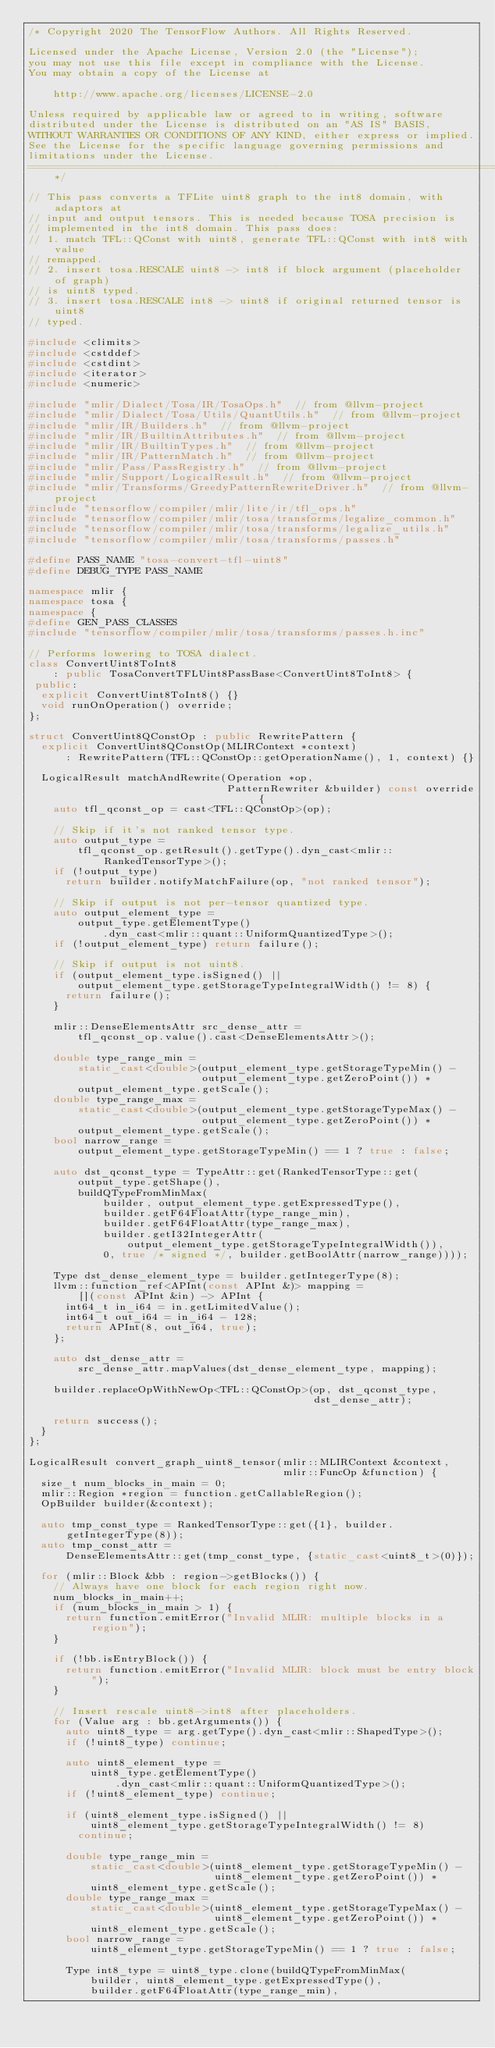Convert code to text. <code><loc_0><loc_0><loc_500><loc_500><_C++_>/* Copyright 2020 The TensorFlow Authors. All Rights Reserved.

Licensed under the Apache License, Version 2.0 (the "License");
you may not use this file except in compliance with the License.
You may obtain a copy of the License at

    http://www.apache.org/licenses/LICENSE-2.0

Unless required by applicable law or agreed to in writing, software
distributed under the License is distributed on an "AS IS" BASIS,
WITHOUT WARRANTIES OR CONDITIONS OF ANY KIND, either express or implied.
See the License for the specific language governing permissions and
limitations under the License.
==============================================================================*/

// This pass converts a TFLite uint8 graph to the int8 domain, with adaptors at
// input and output tensors. This is needed because TOSA precision is
// implemented in the int8 domain. This pass does:
// 1. match TFL::QConst with uint8, generate TFL::QConst with int8 with value
// remapped.
// 2. insert tosa.RESCALE uint8 -> int8 if block argument (placeholder of graph)
// is uint8 typed.
// 3. insert tosa.RESCALE int8 -> uint8 if original returned tensor is uint8
// typed.

#include <climits>
#include <cstddef>
#include <cstdint>
#include <iterator>
#include <numeric>

#include "mlir/Dialect/Tosa/IR/TosaOps.h"  // from @llvm-project
#include "mlir/Dialect/Tosa/Utils/QuantUtils.h"  // from @llvm-project
#include "mlir/IR/Builders.h"  // from @llvm-project
#include "mlir/IR/BuiltinAttributes.h"  // from @llvm-project
#include "mlir/IR/BuiltinTypes.h"  // from @llvm-project
#include "mlir/IR/PatternMatch.h"  // from @llvm-project
#include "mlir/Pass/PassRegistry.h"  // from @llvm-project
#include "mlir/Support/LogicalResult.h"  // from @llvm-project
#include "mlir/Transforms/GreedyPatternRewriteDriver.h"  // from @llvm-project
#include "tensorflow/compiler/mlir/lite/ir/tfl_ops.h"
#include "tensorflow/compiler/mlir/tosa/transforms/legalize_common.h"
#include "tensorflow/compiler/mlir/tosa/transforms/legalize_utils.h"
#include "tensorflow/compiler/mlir/tosa/transforms/passes.h"

#define PASS_NAME "tosa-convert-tfl-uint8"
#define DEBUG_TYPE PASS_NAME

namespace mlir {
namespace tosa {
namespace {
#define GEN_PASS_CLASSES
#include "tensorflow/compiler/mlir/tosa/transforms/passes.h.inc"

// Performs lowering to TOSA dialect.
class ConvertUint8ToInt8
    : public TosaConvertTFLUint8PassBase<ConvertUint8ToInt8> {
 public:
  explicit ConvertUint8ToInt8() {}
  void runOnOperation() override;
};

struct ConvertUint8QConstOp : public RewritePattern {
  explicit ConvertUint8QConstOp(MLIRContext *context)
      : RewritePattern(TFL::QConstOp::getOperationName(), 1, context) {}

  LogicalResult matchAndRewrite(Operation *op,
                                PatternRewriter &builder) const override {
    auto tfl_qconst_op = cast<TFL::QConstOp>(op);

    // Skip if it's not ranked tensor type.
    auto output_type =
        tfl_qconst_op.getResult().getType().dyn_cast<mlir::RankedTensorType>();
    if (!output_type)
      return builder.notifyMatchFailure(op, "not ranked tensor");

    // Skip if output is not per-tensor quantized type.
    auto output_element_type =
        output_type.getElementType()
            .dyn_cast<mlir::quant::UniformQuantizedType>();
    if (!output_element_type) return failure();

    // Skip if output is not uint8.
    if (output_element_type.isSigned() ||
        output_element_type.getStorageTypeIntegralWidth() != 8) {
      return failure();
    }

    mlir::DenseElementsAttr src_dense_attr =
        tfl_qconst_op.value().cast<DenseElementsAttr>();

    double type_range_min =
        static_cast<double>(output_element_type.getStorageTypeMin() -
                            output_element_type.getZeroPoint()) *
        output_element_type.getScale();
    double type_range_max =
        static_cast<double>(output_element_type.getStorageTypeMax() -
                            output_element_type.getZeroPoint()) *
        output_element_type.getScale();
    bool narrow_range =
        output_element_type.getStorageTypeMin() == 1 ? true : false;

    auto dst_qconst_type = TypeAttr::get(RankedTensorType::get(
        output_type.getShape(),
        buildQTypeFromMinMax(
            builder, output_element_type.getExpressedType(),
            builder.getF64FloatAttr(type_range_min),
            builder.getF64FloatAttr(type_range_max),
            builder.getI32IntegerAttr(
                output_element_type.getStorageTypeIntegralWidth()),
            0, true /* signed */, builder.getBoolAttr(narrow_range))));

    Type dst_dense_element_type = builder.getIntegerType(8);
    llvm::function_ref<APInt(const APInt &)> mapping =
        [](const APInt &in) -> APInt {
      int64_t in_i64 = in.getLimitedValue();
      int64_t out_i64 = in_i64 - 128;
      return APInt(8, out_i64, true);
    };

    auto dst_dense_attr =
        src_dense_attr.mapValues(dst_dense_element_type, mapping);

    builder.replaceOpWithNewOp<TFL::QConstOp>(op, dst_qconst_type,
                                              dst_dense_attr);

    return success();
  }
};

LogicalResult convert_graph_uint8_tensor(mlir::MLIRContext &context,
                                         mlir::FuncOp &function) {
  size_t num_blocks_in_main = 0;
  mlir::Region *region = function.getCallableRegion();
  OpBuilder builder(&context);

  auto tmp_const_type = RankedTensorType::get({1}, builder.getIntegerType(8));
  auto tmp_const_attr =
      DenseElementsAttr::get(tmp_const_type, {static_cast<uint8_t>(0)});

  for (mlir::Block &bb : region->getBlocks()) {
    // Always have one block for each region right now.
    num_blocks_in_main++;
    if (num_blocks_in_main > 1) {
      return function.emitError("Invalid MLIR: multiple blocks in a region");
    }

    if (!bb.isEntryBlock()) {
      return function.emitError("Invalid MLIR: block must be entry block");
    }

    // Insert rescale uint8->int8 after placeholders.
    for (Value arg : bb.getArguments()) {
      auto uint8_type = arg.getType().dyn_cast<mlir::ShapedType>();
      if (!uint8_type) continue;

      auto uint8_element_type =
          uint8_type.getElementType()
              .dyn_cast<mlir::quant::UniformQuantizedType>();
      if (!uint8_element_type) continue;

      if (uint8_element_type.isSigned() ||
          uint8_element_type.getStorageTypeIntegralWidth() != 8)
        continue;

      double type_range_min =
          static_cast<double>(uint8_element_type.getStorageTypeMin() -
                              uint8_element_type.getZeroPoint()) *
          uint8_element_type.getScale();
      double type_range_max =
          static_cast<double>(uint8_element_type.getStorageTypeMax() -
                              uint8_element_type.getZeroPoint()) *
          uint8_element_type.getScale();
      bool narrow_range =
          uint8_element_type.getStorageTypeMin() == 1 ? true : false;

      Type int8_type = uint8_type.clone(buildQTypeFromMinMax(
          builder, uint8_element_type.getExpressedType(),
          builder.getF64FloatAttr(type_range_min),</code> 